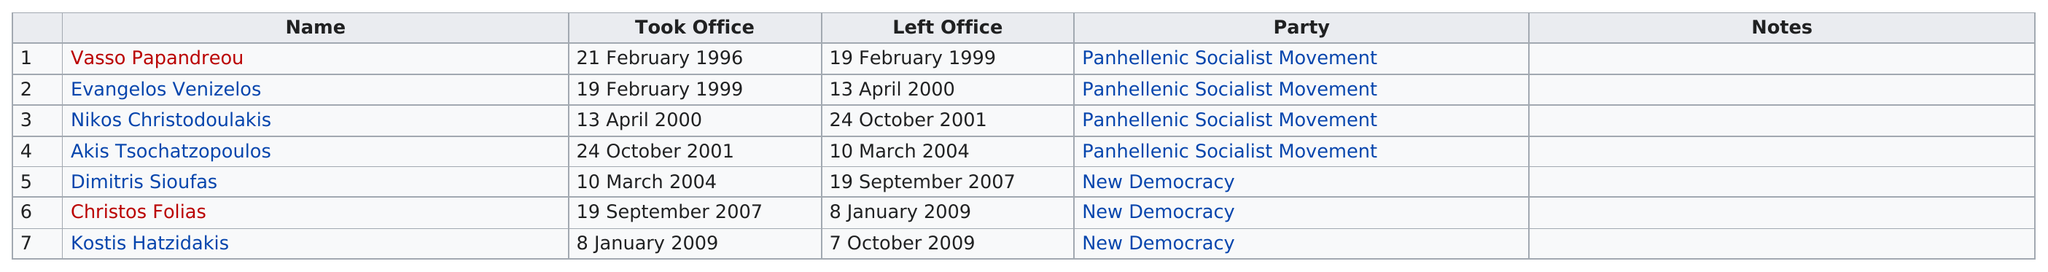Give some essential details in this illustration. In 2007, Christos Folias took office. Dimitris Sioufas was a member of New Democracy. During the year, there were 1 minister who served in office for less than 1 year. Dimitris Sioufas has held the position of Greek Minister of Development for the longest period of time. Nikos Christodoulakis was the first minister to take office in 2000. 